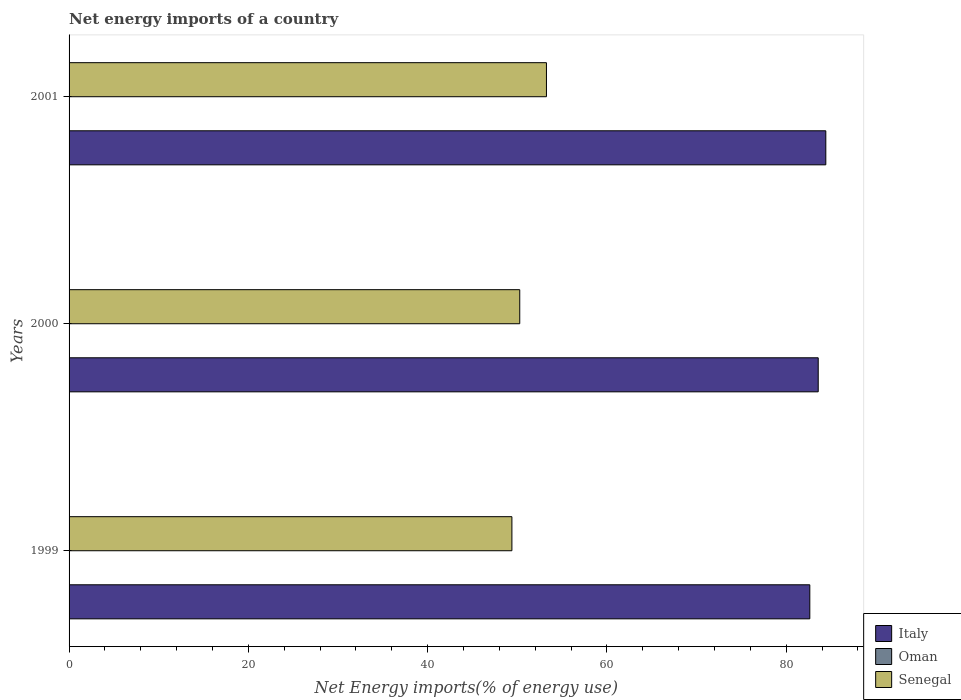How many groups of bars are there?
Give a very brief answer. 3. Are the number of bars per tick equal to the number of legend labels?
Offer a terse response. No. How many bars are there on the 2nd tick from the top?
Keep it short and to the point. 2. What is the label of the 2nd group of bars from the top?
Provide a short and direct response. 2000. In how many cases, is the number of bars for a given year not equal to the number of legend labels?
Your answer should be very brief. 3. What is the net energy imports in Italy in 2000?
Provide a succinct answer. 83.58. Across all years, what is the maximum net energy imports in Italy?
Your answer should be compact. 84.42. Across all years, what is the minimum net energy imports in Senegal?
Provide a succinct answer. 49.4. What is the total net energy imports in Italy in the graph?
Your answer should be very brief. 250.64. What is the difference between the net energy imports in Italy in 1999 and that in 2001?
Your answer should be compact. -1.78. What is the difference between the net energy imports in Italy in 2000 and the net energy imports in Senegal in 2001?
Ensure brevity in your answer.  30.32. What is the average net energy imports in Italy per year?
Ensure brevity in your answer.  83.55. In the year 2001, what is the difference between the net energy imports in Italy and net energy imports in Senegal?
Your response must be concise. 31.17. What is the ratio of the net energy imports in Italy in 1999 to that in 2000?
Offer a terse response. 0.99. Is the net energy imports in Italy in 2000 less than that in 2001?
Ensure brevity in your answer.  Yes. Is the difference between the net energy imports in Italy in 1999 and 2000 greater than the difference between the net energy imports in Senegal in 1999 and 2000?
Give a very brief answer. No. What is the difference between the highest and the second highest net energy imports in Senegal?
Give a very brief answer. 2.98. What is the difference between the highest and the lowest net energy imports in Italy?
Your response must be concise. 1.78. In how many years, is the net energy imports in Oman greater than the average net energy imports in Oman taken over all years?
Give a very brief answer. 0. Is the sum of the net energy imports in Italy in 1999 and 2000 greater than the maximum net energy imports in Oman across all years?
Your answer should be compact. Yes. How many bars are there?
Keep it short and to the point. 6. How many years are there in the graph?
Keep it short and to the point. 3. Are the values on the major ticks of X-axis written in scientific E-notation?
Ensure brevity in your answer.  No. Does the graph contain any zero values?
Your answer should be compact. Yes. Does the graph contain grids?
Provide a short and direct response. No. How many legend labels are there?
Provide a succinct answer. 3. How are the legend labels stacked?
Your answer should be very brief. Vertical. What is the title of the graph?
Ensure brevity in your answer.  Net energy imports of a country. What is the label or title of the X-axis?
Provide a short and direct response. Net Energy imports(% of energy use). What is the label or title of the Y-axis?
Offer a very short reply. Years. What is the Net Energy imports(% of energy use) in Italy in 1999?
Your answer should be very brief. 82.64. What is the Net Energy imports(% of energy use) in Oman in 1999?
Your response must be concise. 0. What is the Net Energy imports(% of energy use) of Senegal in 1999?
Keep it short and to the point. 49.4. What is the Net Energy imports(% of energy use) in Italy in 2000?
Ensure brevity in your answer.  83.58. What is the Net Energy imports(% of energy use) of Senegal in 2000?
Give a very brief answer. 50.28. What is the Net Energy imports(% of energy use) of Italy in 2001?
Ensure brevity in your answer.  84.42. What is the Net Energy imports(% of energy use) in Senegal in 2001?
Provide a succinct answer. 53.26. Across all years, what is the maximum Net Energy imports(% of energy use) of Italy?
Keep it short and to the point. 84.42. Across all years, what is the maximum Net Energy imports(% of energy use) of Senegal?
Offer a terse response. 53.26. Across all years, what is the minimum Net Energy imports(% of energy use) of Italy?
Your response must be concise. 82.64. Across all years, what is the minimum Net Energy imports(% of energy use) of Senegal?
Keep it short and to the point. 49.4. What is the total Net Energy imports(% of energy use) of Italy in the graph?
Make the answer very short. 250.64. What is the total Net Energy imports(% of energy use) of Oman in the graph?
Offer a very short reply. 0. What is the total Net Energy imports(% of energy use) in Senegal in the graph?
Provide a short and direct response. 152.94. What is the difference between the Net Energy imports(% of energy use) in Italy in 1999 and that in 2000?
Make the answer very short. -0.94. What is the difference between the Net Energy imports(% of energy use) of Senegal in 1999 and that in 2000?
Keep it short and to the point. -0.88. What is the difference between the Net Energy imports(% of energy use) in Italy in 1999 and that in 2001?
Provide a succinct answer. -1.78. What is the difference between the Net Energy imports(% of energy use) in Senegal in 1999 and that in 2001?
Provide a short and direct response. -3.85. What is the difference between the Net Energy imports(% of energy use) of Italy in 2000 and that in 2001?
Make the answer very short. -0.85. What is the difference between the Net Energy imports(% of energy use) in Senegal in 2000 and that in 2001?
Ensure brevity in your answer.  -2.98. What is the difference between the Net Energy imports(% of energy use) in Italy in 1999 and the Net Energy imports(% of energy use) in Senegal in 2000?
Ensure brevity in your answer.  32.36. What is the difference between the Net Energy imports(% of energy use) in Italy in 1999 and the Net Energy imports(% of energy use) in Senegal in 2001?
Your answer should be compact. 29.38. What is the difference between the Net Energy imports(% of energy use) in Italy in 2000 and the Net Energy imports(% of energy use) in Senegal in 2001?
Offer a terse response. 30.32. What is the average Net Energy imports(% of energy use) of Italy per year?
Your answer should be compact. 83.55. What is the average Net Energy imports(% of energy use) of Oman per year?
Your answer should be compact. 0. What is the average Net Energy imports(% of energy use) of Senegal per year?
Provide a short and direct response. 50.98. In the year 1999, what is the difference between the Net Energy imports(% of energy use) in Italy and Net Energy imports(% of energy use) in Senegal?
Your response must be concise. 33.24. In the year 2000, what is the difference between the Net Energy imports(% of energy use) in Italy and Net Energy imports(% of energy use) in Senegal?
Make the answer very short. 33.3. In the year 2001, what is the difference between the Net Energy imports(% of energy use) of Italy and Net Energy imports(% of energy use) of Senegal?
Keep it short and to the point. 31.17. What is the ratio of the Net Energy imports(% of energy use) of Senegal in 1999 to that in 2000?
Your answer should be very brief. 0.98. What is the ratio of the Net Energy imports(% of energy use) of Italy in 1999 to that in 2001?
Ensure brevity in your answer.  0.98. What is the ratio of the Net Energy imports(% of energy use) of Senegal in 1999 to that in 2001?
Offer a terse response. 0.93. What is the ratio of the Net Energy imports(% of energy use) in Senegal in 2000 to that in 2001?
Your response must be concise. 0.94. What is the difference between the highest and the second highest Net Energy imports(% of energy use) in Italy?
Your answer should be compact. 0.85. What is the difference between the highest and the second highest Net Energy imports(% of energy use) in Senegal?
Your answer should be very brief. 2.98. What is the difference between the highest and the lowest Net Energy imports(% of energy use) in Italy?
Ensure brevity in your answer.  1.78. What is the difference between the highest and the lowest Net Energy imports(% of energy use) of Senegal?
Make the answer very short. 3.85. 